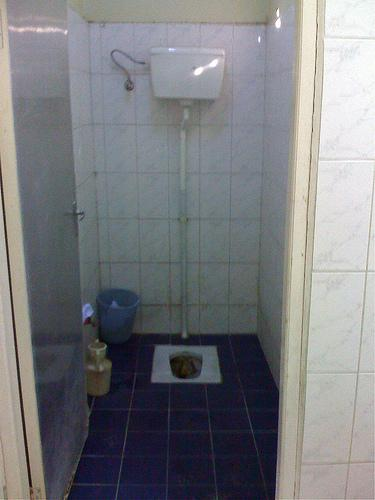Question: what color is the floor tile?
Choices:
A. The tile is dark blue.
B. Black.
C. White.
D. Brown.
Answer with the letter. Answer: A Question: what color is the wall tile?
Choices:
A. The wall tile is white.
B. Black.
C. Grey.
D. Brown.
Answer with the letter. Answer: A Question: what is in the bathroom?
Choices:
A. Toilet paper.
B. A blue bucket.
C. Bar of soap.
D. Trash can.
Answer with the letter. Answer: B Question: who is taking the picture?
Choices:
A. A child.
B. A photographer.
C. The grandmother.
D. The father.
Answer with the letter. Answer: B 